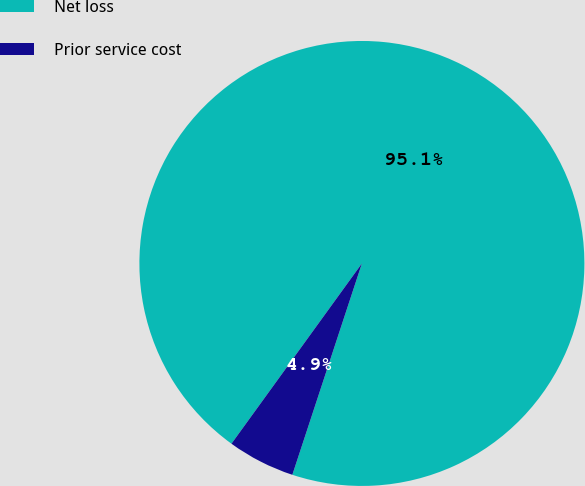Convert chart. <chart><loc_0><loc_0><loc_500><loc_500><pie_chart><fcel>Net loss<fcel>Prior service cost<nl><fcel>95.09%<fcel>4.91%<nl></chart> 